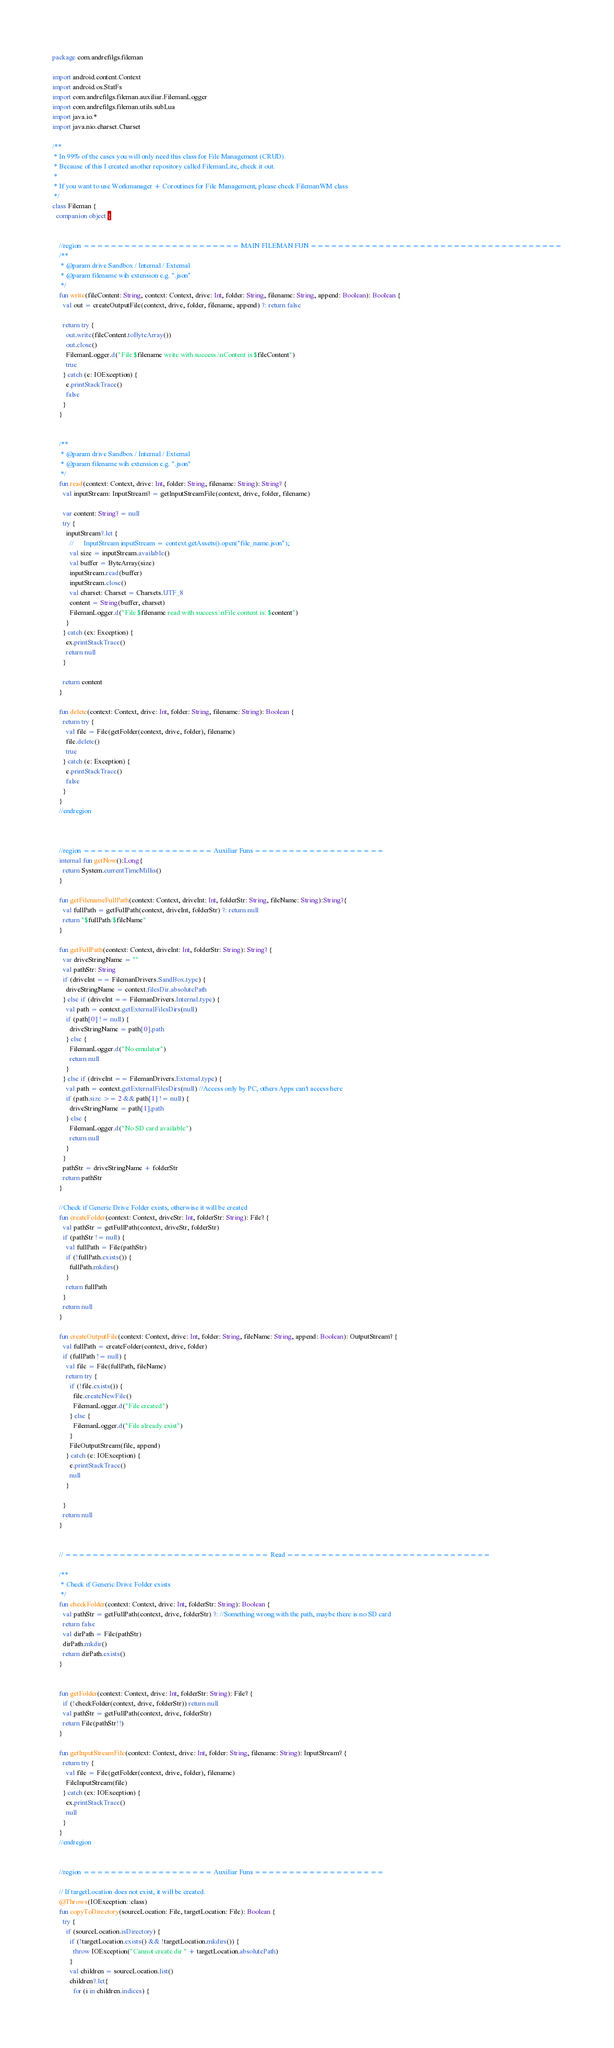Convert code to text. <code><loc_0><loc_0><loc_500><loc_500><_Kotlin_>package com.andrefilgs.fileman

import android.content.Context
import android.os.StatFs
import com.andrefilgs.fileman.auxiliar.FilemanLogger
import com.andrefilgs.fileman.utils.subLua
import java.io.*
import java.nio.charset.Charset

/**
 * In 99% of the cases you will only need this class for File Management (CRUD).
 * Because of this I created another repository called FilemanLite, check it out.
 *
 * If you want to use Workmanager + Coroutines for File Management, please check FilemanWM class
 */
class Fileman {
  companion object {

    
    //region ======================= MAIN FILEMAN FUN =====================================
    /**
     * @param drive Sandbox / Internal / External
     * @param filename wih extension e.g. ".json"
     */
    fun write(fileContent: String, context: Context, drive: Int, folder: String, filename: String, append: Boolean): Boolean {
      val out = createOutputFile(context, drive, folder, filename, append) ?: return false
      
      return try {
        out.write(fileContent.toByteArray())
        out.close()
        FilemanLogger.d("File $filename write with success.\nContent is $fileContent")
        true
      } catch (e: IOException) {
        e.printStackTrace()
        false
      }
    }
    
    
    /**
     * @param drive Sandbox / Internal / External
     * @param filename wih extension e.g. ".json"
     */
    fun read(context: Context, drive: Int, folder: String, filename: String): String? {
      val inputStream: InputStream? = getInputStreamFile(context, drive, folder, filename)
      
      var content: String? = null
      try {
        inputStream?.let {
          //      InputStream inputStream = context.getAssets().open("file_name.json");
          val size = inputStream.available()
          val buffer = ByteArray(size)
          inputStream.read(buffer)
          inputStream.close()
          val charset: Charset = Charsets.UTF_8
          content = String(buffer, charset)
          FilemanLogger.d("File $filename read with success.\nFile content is: $content")
        }
      } catch (ex: Exception) {
        ex.printStackTrace()
        return null
      }
      
      return content
    }
    
    fun delete(context: Context, drive: Int, folder: String, filename: String): Boolean {
      return try {
        val file = File(getFolder(context, drive, folder), filename)
        file.delete()
        true
      } catch (e: Exception) {
        e.printStackTrace()
        false
      }
    }
    //endregion
  
  
  
    //region =================== Auxiliar Funs ===================
    internal fun getNow():Long{
      return System.currentTimeMillis()
    }
  
    fun getFilenameFullPath(context: Context, driveInt: Int, folderStr: String, fileName: String):String?{
      val fullPath = getFullPath(context, driveInt, folderStr) ?: return null
      return "$fullPath/$fileName"
    }
  
    fun getFullPath(context: Context, driveInt: Int, folderStr: String): String? {
      var driveStringName = ""
      val pathStr: String
      if (driveInt == FilemanDrivers.SandBox.type) {
        driveStringName = context.filesDir.absolutePath
      } else if (driveInt == FilemanDrivers.Internal.type) {
        val path = context.getExternalFilesDirs(null)
        if (path[0] != null) {
          driveStringName = path[0].path
        } else {
          FilemanLogger.d("No emulator")
          return null
        }
      } else if (driveInt == FilemanDrivers.External.type) {
        val path = context.getExternalFilesDirs(null) //Access only by PC, others Apps can't access here
        if (path.size >= 2 && path[1] != null) {
          driveStringName = path[1].path
        } else {
          FilemanLogger.d("No SD card available")
          return null
        }
      }
      pathStr = driveStringName + folderStr
      return pathStr
    }
  
    //Check if Generic Drive Folder exists, otherwise it will be created
    fun createFolder(context: Context, driveStr: Int, folderStr: String): File? {
      val pathStr = getFullPath(context, driveStr, folderStr)
      if (pathStr != null) {
        val fullPath = File(pathStr)
        if (!fullPath.exists()) {
          fullPath.mkdirs()
        }
        return fullPath
      }
      return null
    }
  
    fun createOutputFile(context: Context, drive: Int, folder: String, fileName: String, append: Boolean): OutputStream? {
      val fullPath = createFolder(context, drive, folder)
      if (fullPath != null) {
        val file = File(fullPath, fileName)
        return try {
          if (!file.exists()) {
            file.createNewFile()
            FilemanLogger.d("File created")
          } else {
            FilemanLogger.d("File already exist")
          }
          FileOutputStream(file, append)
        } catch (e: IOException) {
          e.printStackTrace()
          null
        }
      
      }
      return null
    }
  
  
    // ============================== Read ==============================
  
    /**
     * Check if Generic Drive Folder exists
     */
    fun checkFolder(context: Context, drive: Int, folderStr: String): Boolean {
      val pathStr = getFullPath(context, drive, folderStr) ?: //Something wrong with the path, maybe there is no SD card
      return false
      val dirPath = File(pathStr)
      dirPath.mkdir()
      return dirPath.exists()
    }
  
  
    fun getFolder(context: Context, drive: Int, folderStr: String): File? {
      if (!checkFolder(context, drive, folderStr)) return null
      val pathStr = getFullPath(context, drive, folderStr)
      return File(pathStr!!)
    }
  
    fun getInputStreamFile(context: Context, drive: Int, folder: String, filename: String): InputStream? {
      return try {
        val file = File(getFolder(context, drive, folder), filename)
        FileInputStream(file)
      } catch (ex: IOException) {
        ex.printStackTrace()
        null
      }
    }
    //endregion
    
    
    //region =================== Auxiliar Funs ===================
  
    // If targetLocation does not exist, it will be created.
    @Throws(IOException::class)
    fun copyToDirectory(sourceLocation: File, targetLocation: File): Boolean {
      try {
        if (sourceLocation.isDirectory) {
          if (!targetLocation.exists() && !targetLocation.mkdirs()) {
            throw IOException("Cannot create dir " + targetLocation.absolutePath)
          }
          val children = sourceLocation.list()
          children?.let{
            for (i in children.indices) {</code> 